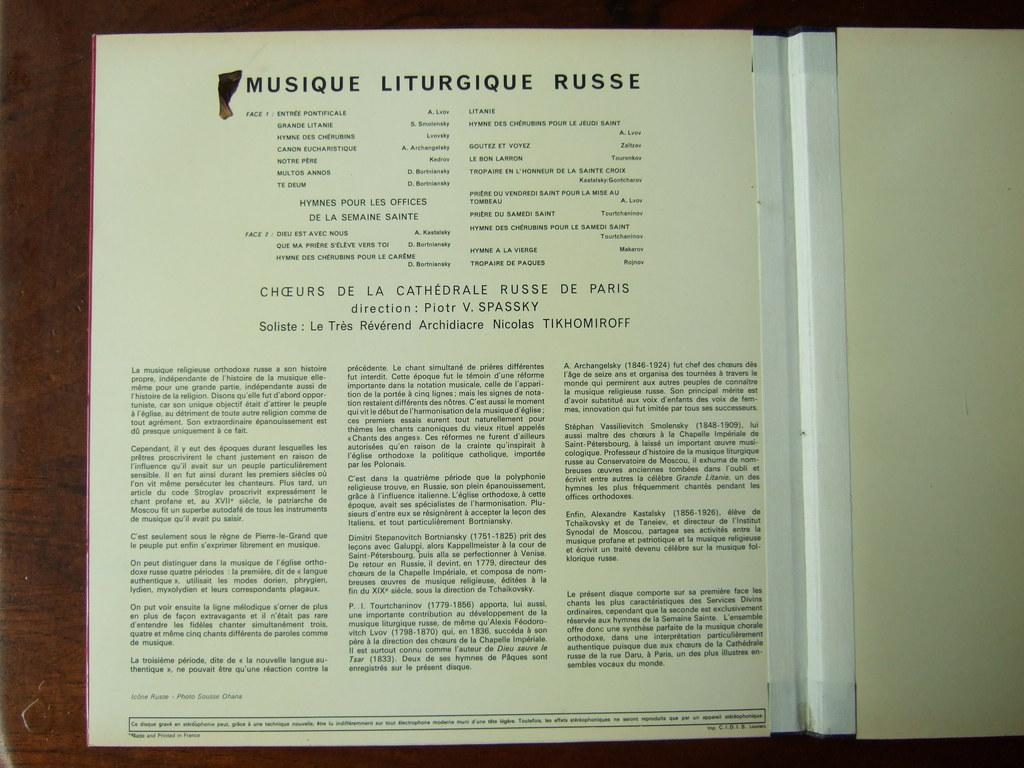What is the main subject in the center of the image? There is a book in the center of the image. What can be found inside the book? The book contains text. On what surface is the book placed? The book is placed on a wooden object, which appears to be a table. How many wheels are visible on the book in the image? There are no wheels visible on the book in the image, as books do not have wheels. 